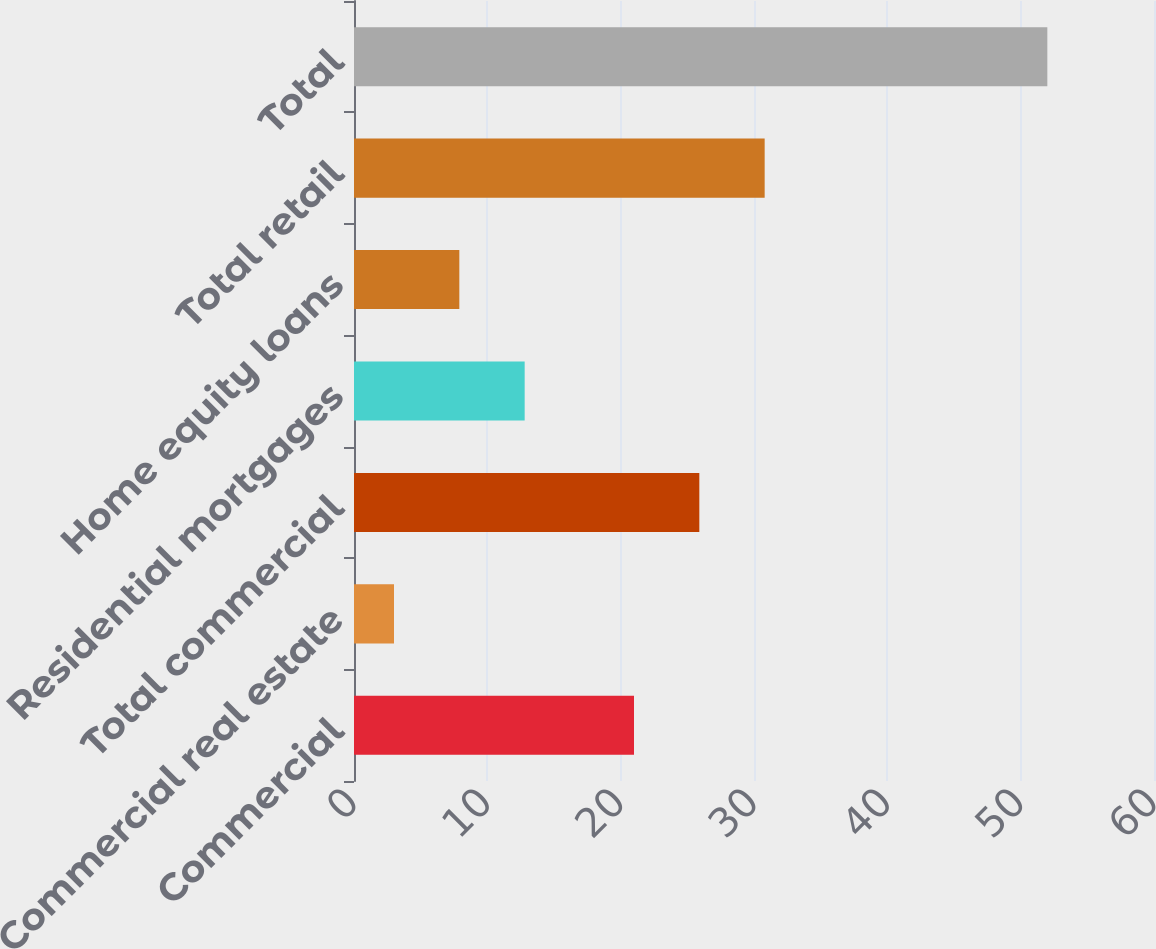Convert chart to OTSL. <chart><loc_0><loc_0><loc_500><loc_500><bar_chart><fcel>Commercial<fcel>Commercial real estate<fcel>Total commercial<fcel>Residential mortgages<fcel>Home equity loans<fcel>Total retail<fcel>Total<nl><fcel>21<fcel>3<fcel>25.9<fcel>12.8<fcel>7.9<fcel>30.8<fcel>52<nl></chart> 